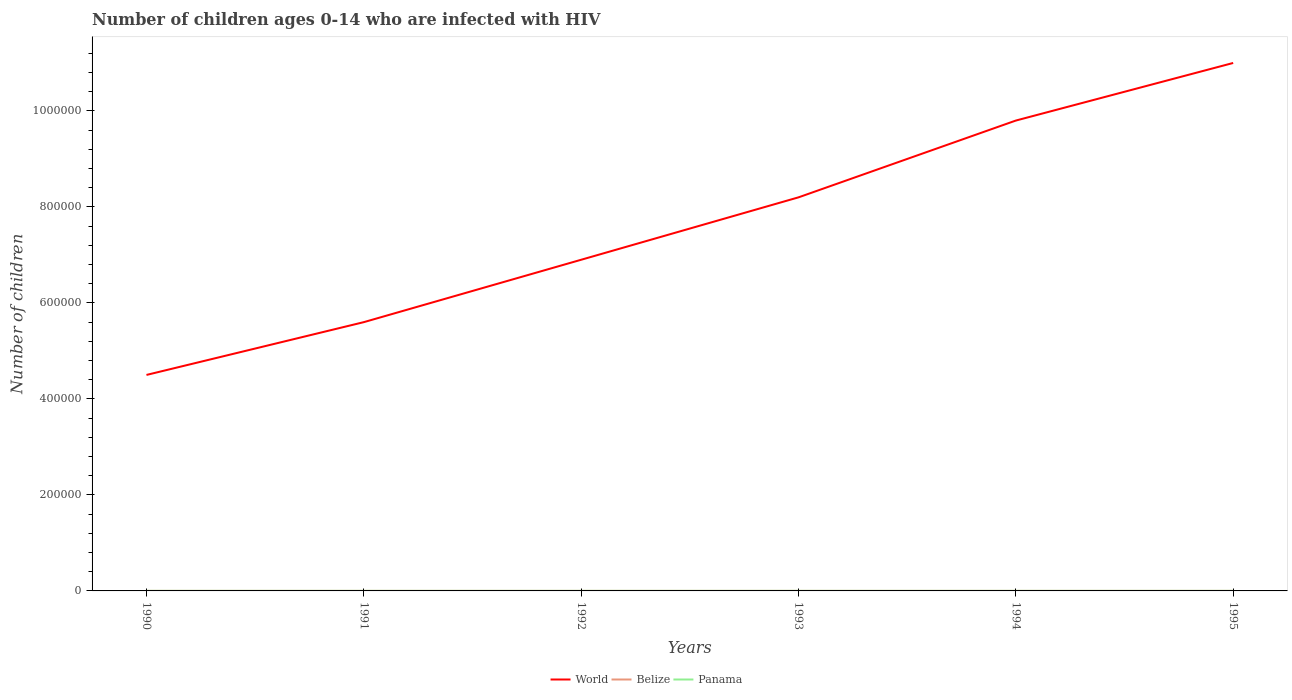Is the number of lines equal to the number of legend labels?
Provide a succinct answer. Yes. Across all years, what is the maximum number of HIV infected children in World?
Your answer should be compact. 4.50e+05. In which year was the number of HIV infected children in Belize maximum?
Provide a succinct answer. 1990. What is the difference between the highest and the lowest number of HIV infected children in Panama?
Ensure brevity in your answer.  0. How many lines are there?
Make the answer very short. 3. Are the values on the major ticks of Y-axis written in scientific E-notation?
Provide a succinct answer. No. Does the graph contain any zero values?
Make the answer very short. No. Does the graph contain grids?
Make the answer very short. No. What is the title of the graph?
Give a very brief answer. Number of children ages 0-14 who are infected with HIV. What is the label or title of the X-axis?
Make the answer very short. Years. What is the label or title of the Y-axis?
Your answer should be very brief. Number of children. What is the Number of children of World in 1990?
Provide a succinct answer. 4.50e+05. What is the Number of children of Belize in 1990?
Provide a succinct answer. 100. What is the Number of children of Panama in 1990?
Give a very brief answer. 100. What is the Number of children of World in 1991?
Make the answer very short. 5.60e+05. What is the Number of children in World in 1992?
Provide a succinct answer. 6.90e+05. What is the Number of children in Belize in 1992?
Your answer should be very brief. 100. What is the Number of children in World in 1993?
Give a very brief answer. 8.20e+05. What is the Number of children in Belize in 1993?
Make the answer very short. 100. What is the Number of children in World in 1994?
Offer a very short reply. 9.80e+05. What is the Number of children in Belize in 1994?
Your answer should be compact. 100. What is the Number of children of Panama in 1994?
Provide a short and direct response. 100. What is the Number of children of World in 1995?
Your answer should be compact. 1.10e+06. What is the Number of children in Panama in 1995?
Make the answer very short. 100. Across all years, what is the maximum Number of children in World?
Your answer should be very brief. 1.10e+06. Across all years, what is the maximum Number of children in Belize?
Offer a very short reply. 100. Across all years, what is the maximum Number of children in Panama?
Offer a very short reply. 100. Across all years, what is the minimum Number of children in World?
Provide a short and direct response. 4.50e+05. What is the total Number of children in World in the graph?
Offer a very short reply. 4.60e+06. What is the total Number of children of Belize in the graph?
Make the answer very short. 600. What is the total Number of children of Panama in the graph?
Provide a succinct answer. 600. What is the difference between the Number of children of Panama in 1990 and that in 1991?
Your answer should be compact. 0. What is the difference between the Number of children of World in 1990 and that in 1993?
Keep it short and to the point. -3.70e+05. What is the difference between the Number of children of Panama in 1990 and that in 1993?
Make the answer very short. 0. What is the difference between the Number of children of World in 1990 and that in 1994?
Your response must be concise. -5.30e+05. What is the difference between the Number of children in Belize in 1990 and that in 1994?
Offer a very short reply. 0. What is the difference between the Number of children in World in 1990 and that in 1995?
Give a very brief answer. -6.50e+05. What is the difference between the Number of children in World in 1991 and that in 1992?
Provide a succinct answer. -1.30e+05. What is the difference between the Number of children of Belize in 1991 and that in 1992?
Ensure brevity in your answer.  0. What is the difference between the Number of children of Panama in 1991 and that in 1992?
Ensure brevity in your answer.  0. What is the difference between the Number of children of World in 1991 and that in 1993?
Your answer should be compact. -2.60e+05. What is the difference between the Number of children of Panama in 1991 and that in 1993?
Make the answer very short. 0. What is the difference between the Number of children in World in 1991 and that in 1994?
Keep it short and to the point. -4.20e+05. What is the difference between the Number of children of Belize in 1991 and that in 1994?
Ensure brevity in your answer.  0. What is the difference between the Number of children in Panama in 1991 and that in 1994?
Make the answer very short. 0. What is the difference between the Number of children of World in 1991 and that in 1995?
Your answer should be compact. -5.40e+05. What is the difference between the Number of children of Belize in 1991 and that in 1995?
Ensure brevity in your answer.  0. What is the difference between the Number of children in Belize in 1992 and that in 1993?
Offer a terse response. 0. What is the difference between the Number of children of World in 1992 and that in 1994?
Give a very brief answer. -2.90e+05. What is the difference between the Number of children in Panama in 1992 and that in 1994?
Offer a terse response. 0. What is the difference between the Number of children in World in 1992 and that in 1995?
Offer a very short reply. -4.10e+05. What is the difference between the Number of children of Panama in 1992 and that in 1995?
Offer a very short reply. 0. What is the difference between the Number of children of Panama in 1993 and that in 1994?
Make the answer very short. 0. What is the difference between the Number of children of World in 1993 and that in 1995?
Keep it short and to the point. -2.80e+05. What is the difference between the Number of children in World in 1994 and that in 1995?
Your answer should be very brief. -1.20e+05. What is the difference between the Number of children of Belize in 1994 and that in 1995?
Make the answer very short. 0. What is the difference between the Number of children of World in 1990 and the Number of children of Belize in 1991?
Offer a very short reply. 4.50e+05. What is the difference between the Number of children in World in 1990 and the Number of children in Panama in 1991?
Keep it short and to the point. 4.50e+05. What is the difference between the Number of children in World in 1990 and the Number of children in Belize in 1992?
Give a very brief answer. 4.50e+05. What is the difference between the Number of children in World in 1990 and the Number of children in Panama in 1992?
Your answer should be compact. 4.50e+05. What is the difference between the Number of children in Belize in 1990 and the Number of children in Panama in 1992?
Offer a very short reply. 0. What is the difference between the Number of children of World in 1990 and the Number of children of Belize in 1993?
Make the answer very short. 4.50e+05. What is the difference between the Number of children of World in 1990 and the Number of children of Panama in 1993?
Give a very brief answer. 4.50e+05. What is the difference between the Number of children in Belize in 1990 and the Number of children in Panama in 1993?
Offer a very short reply. 0. What is the difference between the Number of children in World in 1990 and the Number of children in Belize in 1994?
Provide a short and direct response. 4.50e+05. What is the difference between the Number of children of World in 1990 and the Number of children of Panama in 1994?
Provide a succinct answer. 4.50e+05. What is the difference between the Number of children of World in 1990 and the Number of children of Belize in 1995?
Your answer should be very brief. 4.50e+05. What is the difference between the Number of children of World in 1990 and the Number of children of Panama in 1995?
Provide a succinct answer. 4.50e+05. What is the difference between the Number of children in Belize in 1990 and the Number of children in Panama in 1995?
Your answer should be compact. 0. What is the difference between the Number of children in World in 1991 and the Number of children in Belize in 1992?
Give a very brief answer. 5.60e+05. What is the difference between the Number of children of World in 1991 and the Number of children of Panama in 1992?
Your response must be concise. 5.60e+05. What is the difference between the Number of children of Belize in 1991 and the Number of children of Panama in 1992?
Ensure brevity in your answer.  0. What is the difference between the Number of children of World in 1991 and the Number of children of Belize in 1993?
Ensure brevity in your answer.  5.60e+05. What is the difference between the Number of children of World in 1991 and the Number of children of Panama in 1993?
Provide a succinct answer. 5.60e+05. What is the difference between the Number of children of Belize in 1991 and the Number of children of Panama in 1993?
Provide a succinct answer. 0. What is the difference between the Number of children of World in 1991 and the Number of children of Belize in 1994?
Your response must be concise. 5.60e+05. What is the difference between the Number of children in World in 1991 and the Number of children in Panama in 1994?
Offer a very short reply. 5.60e+05. What is the difference between the Number of children of World in 1991 and the Number of children of Belize in 1995?
Ensure brevity in your answer.  5.60e+05. What is the difference between the Number of children in World in 1991 and the Number of children in Panama in 1995?
Provide a succinct answer. 5.60e+05. What is the difference between the Number of children of World in 1992 and the Number of children of Belize in 1993?
Your answer should be compact. 6.90e+05. What is the difference between the Number of children of World in 1992 and the Number of children of Panama in 1993?
Your answer should be compact. 6.90e+05. What is the difference between the Number of children of World in 1992 and the Number of children of Belize in 1994?
Make the answer very short. 6.90e+05. What is the difference between the Number of children of World in 1992 and the Number of children of Panama in 1994?
Give a very brief answer. 6.90e+05. What is the difference between the Number of children in Belize in 1992 and the Number of children in Panama in 1994?
Your answer should be very brief. 0. What is the difference between the Number of children of World in 1992 and the Number of children of Belize in 1995?
Make the answer very short. 6.90e+05. What is the difference between the Number of children in World in 1992 and the Number of children in Panama in 1995?
Offer a terse response. 6.90e+05. What is the difference between the Number of children of Belize in 1992 and the Number of children of Panama in 1995?
Offer a very short reply. 0. What is the difference between the Number of children in World in 1993 and the Number of children in Belize in 1994?
Ensure brevity in your answer.  8.20e+05. What is the difference between the Number of children in World in 1993 and the Number of children in Panama in 1994?
Provide a short and direct response. 8.20e+05. What is the difference between the Number of children of Belize in 1993 and the Number of children of Panama in 1994?
Offer a very short reply. 0. What is the difference between the Number of children of World in 1993 and the Number of children of Belize in 1995?
Provide a succinct answer. 8.20e+05. What is the difference between the Number of children of World in 1993 and the Number of children of Panama in 1995?
Make the answer very short. 8.20e+05. What is the difference between the Number of children of Belize in 1993 and the Number of children of Panama in 1995?
Make the answer very short. 0. What is the difference between the Number of children of World in 1994 and the Number of children of Belize in 1995?
Provide a succinct answer. 9.80e+05. What is the difference between the Number of children in World in 1994 and the Number of children in Panama in 1995?
Your answer should be very brief. 9.80e+05. What is the average Number of children of World per year?
Your answer should be compact. 7.67e+05. What is the average Number of children of Belize per year?
Your response must be concise. 100. What is the average Number of children in Panama per year?
Give a very brief answer. 100. In the year 1990, what is the difference between the Number of children of World and Number of children of Belize?
Make the answer very short. 4.50e+05. In the year 1990, what is the difference between the Number of children of World and Number of children of Panama?
Your response must be concise. 4.50e+05. In the year 1990, what is the difference between the Number of children in Belize and Number of children in Panama?
Make the answer very short. 0. In the year 1991, what is the difference between the Number of children in World and Number of children in Belize?
Ensure brevity in your answer.  5.60e+05. In the year 1991, what is the difference between the Number of children of World and Number of children of Panama?
Offer a terse response. 5.60e+05. In the year 1992, what is the difference between the Number of children in World and Number of children in Belize?
Provide a short and direct response. 6.90e+05. In the year 1992, what is the difference between the Number of children of World and Number of children of Panama?
Your answer should be very brief. 6.90e+05. In the year 1993, what is the difference between the Number of children in World and Number of children in Belize?
Your answer should be compact. 8.20e+05. In the year 1993, what is the difference between the Number of children in World and Number of children in Panama?
Keep it short and to the point. 8.20e+05. In the year 1994, what is the difference between the Number of children of World and Number of children of Belize?
Ensure brevity in your answer.  9.80e+05. In the year 1994, what is the difference between the Number of children of World and Number of children of Panama?
Your response must be concise. 9.80e+05. In the year 1995, what is the difference between the Number of children of World and Number of children of Belize?
Give a very brief answer. 1.10e+06. In the year 1995, what is the difference between the Number of children of World and Number of children of Panama?
Your answer should be compact. 1.10e+06. What is the ratio of the Number of children of World in 1990 to that in 1991?
Offer a very short reply. 0.8. What is the ratio of the Number of children in Belize in 1990 to that in 1991?
Your answer should be compact. 1. What is the ratio of the Number of children in World in 1990 to that in 1992?
Make the answer very short. 0.65. What is the ratio of the Number of children of Panama in 1990 to that in 1992?
Keep it short and to the point. 1. What is the ratio of the Number of children in World in 1990 to that in 1993?
Your response must be concise. 0.55. What is the ratio of the Number of children in Belize in 1990 to that in 1993?
Your answer should be compact. 1. What is the ratio of the Number of children in World in 1990 to that in 1994?
Make the answer very short. 0.46. What is the ratio of the Number of children of Panama in 1990 to that in 1994?
Ensure brevity in your answer.  1. What is the ratio of the Number of children of World in 1990 to that in 1995?
Offer a very short reply. 0.41. What is the ratio of the Number of children of Belize in 1990 to that in 1995?
Ensure brevity in your answer.  1. What is the ratio of the Number of children of Panama in 1990 to that in 1995?
Your answer should be compact. 1. What is the ratio of the Number of children of World in 1991 to that in 1992?
Your answer should be very brief. 0.81. What is the ratio of the Number of children of Belize in 1991 to that in 1992?
Offer a terse response. 1. What is the ratio of the Number of children of Panama in 1991 to that in 1992?
Ensure brevity in your answer.  1. What is the ratio of the Number of children of World in 1991 to that in 1993?
Your answer should be very brief. 0.68. What is the ratio of the Number of children in Belize in 1991 to that in 1994?
Give a very brief answer. 1. What is the ratio of the Number of children of Panama in 1991 to that in 1994?
Ensure brevity in your answer.  1. What is the ratio of the Number of children of World in 1991 to that in 1995?
Provide a succinct answer. 0.51. What is the ratio of the Number of children in World in 1992 to that in 1993?
Give a very brief answer. 0.84. What is the ratio of the Number of children in Panama in 1992 to that in 1993?
Your answer should be very brief. 1. What is the ratio of the Number of children of World in 1992 to that in 1994?
Make the answer very short. 0.7. What is the ratio of the Number of children in World in 1992 to that in 1995?
Make the answer very short. 0.63. What is the ratio of the Number of children of Belize in 1992 to that in 1995?
Ensure brevity in your answer.  1. What is the ratio of the Number of children in Panama in 1992 to that in 1995?
Your answer should be very brief. 1. What is the ratio of the Number of children of World in 1993 to that in 1994?
Your answer should be compact. 0.84. What is the ratio of the Number of children of Belize in 1993 to that in 1994?
Your answer should be very brief. 1. What is the ratio of the Number of children in World in 1993 to that in 1995?
Ensure brevity in your answer.  0.75. What is the ratio of the Number of children of Panama in 1993 to that in 1995?
Provide a succinct answer. 1. What is the ratio of the Number of children of World in 1994 to that in 1995?
Provide a short and direct response. 0.89. What is the difference between the highest and the second highest Number of children in World?
Your response must be concise. 1.20e+05. What is the difference between the highest and the second highest Number of children of Belize?
Give a very brief answer. 0. What is the difference between the highest and the second highest Number of children of Panama?
Ensure brevity in your answer.  0. What is the difference between the highest and the lowest Number of children in World?
Offer a very short reply. 6.50e+05. 